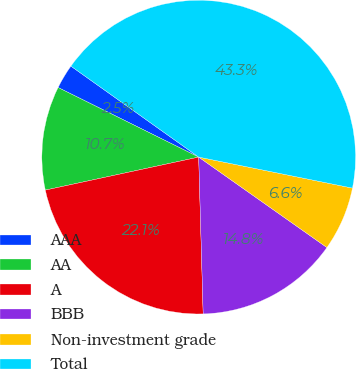<chart> <loc_0><loc_0><loc_500><loc_500><pie_chart><fcel>AAA<fcel>AA<fcel>A<fcel>BBB<fcel>Non-investment grade<fcel>Total<nl><fcel>2.53%<fcel>10.69%<fcel>22.08%<fcel>14.77%<fcel>6.61%<fcel>43.32%<nl></chart> 